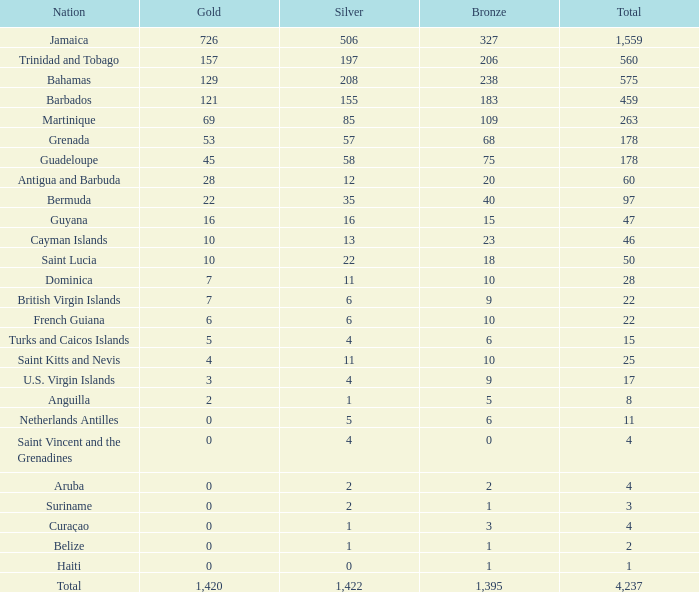What's the total number of Silver that has Gold that's larger than 0, Bronze that's smaller than 23, a Total that's larger than 22, and has the Nation of Saint Kitts and Nevis? 1.0. 